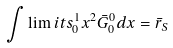<formula> <loc_0><loc_0><loc_500><loc_500>\int \lim i t s _ { 0 } ^ { 1 } x ^ { 2 } \bar { G } ^ { 0 } _ { 0 } d x = \bar { r } _ { S }</formula> 